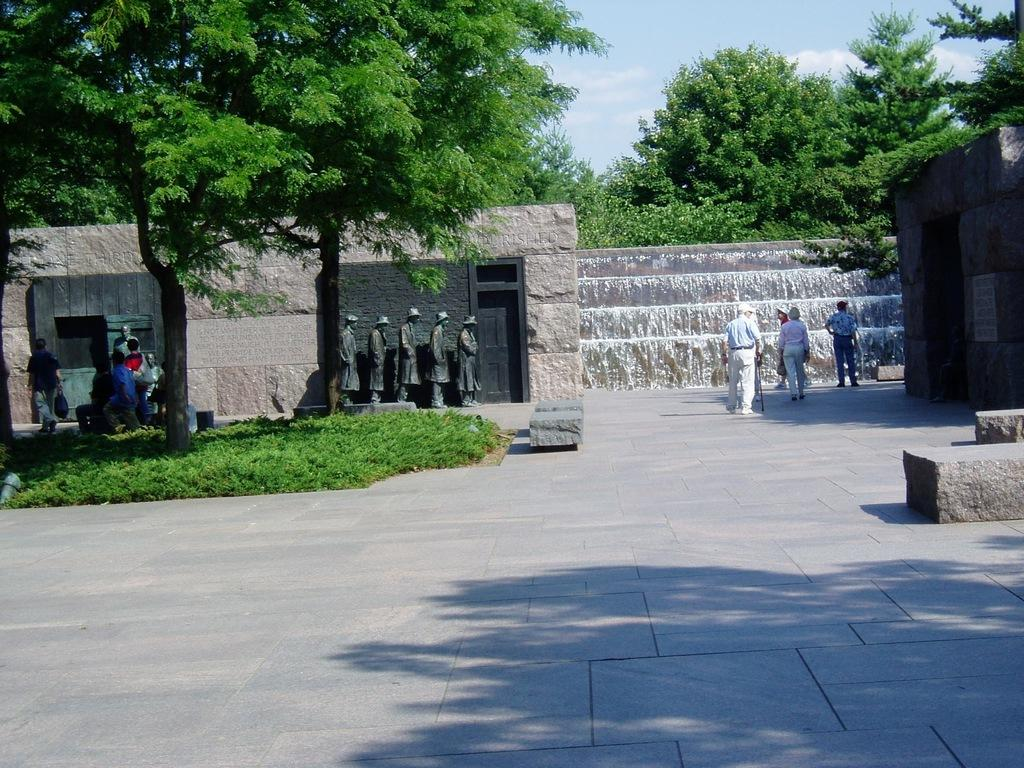What can be seen in the foreground of the image? There are people, statues, and walls in the foreground of the image. What is the main feature in the background of the image? It appears to be a waterfall in the background of the image. What other elements can be seen in the background of the image? There are trees and the sky visible in the background of the image. Can you tell me how many trucks are parked near the waterfall in the image? There are no trucks present in the image; it features people, statues, walls, a waterfall, trees, and the sky. Is there any poison visible in the image? There is no poison present in the image. 